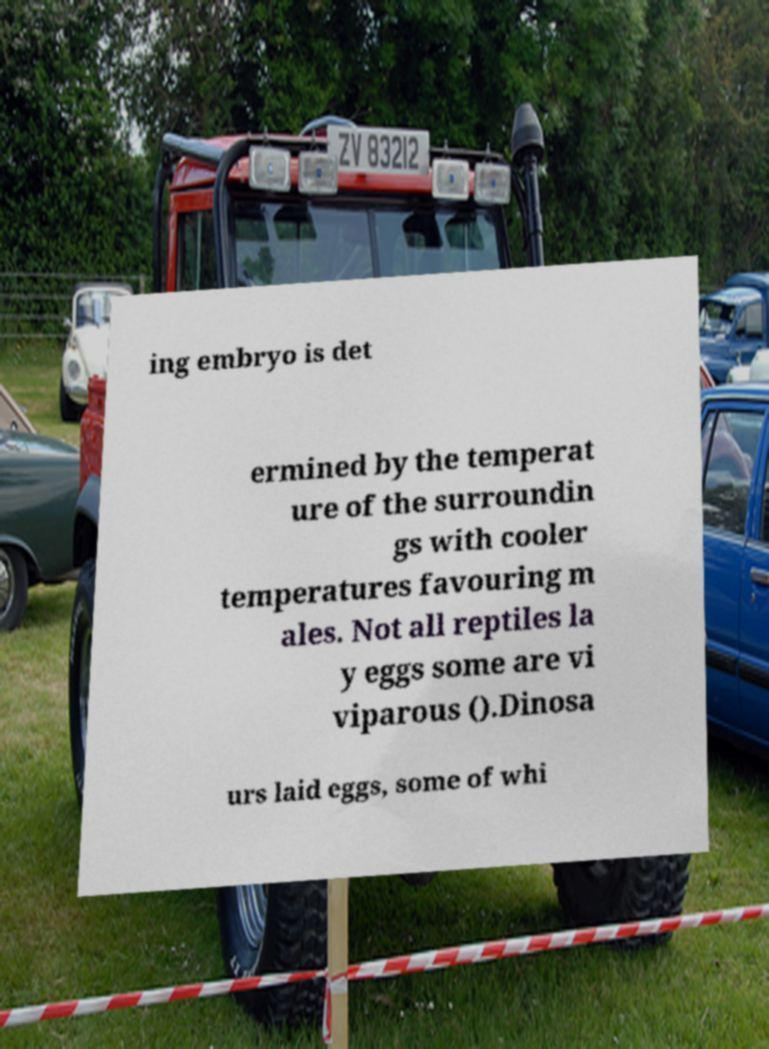Could you assist in decoding the text presented in this image and type it out clearly? ing embryo is det ermined by the temperat ure of the surroundin gs with cooler temperatures favouring m ales. Not all reptiles la y eggs some are vi viparous ().Dinosa urs laid eggs, some of whi 